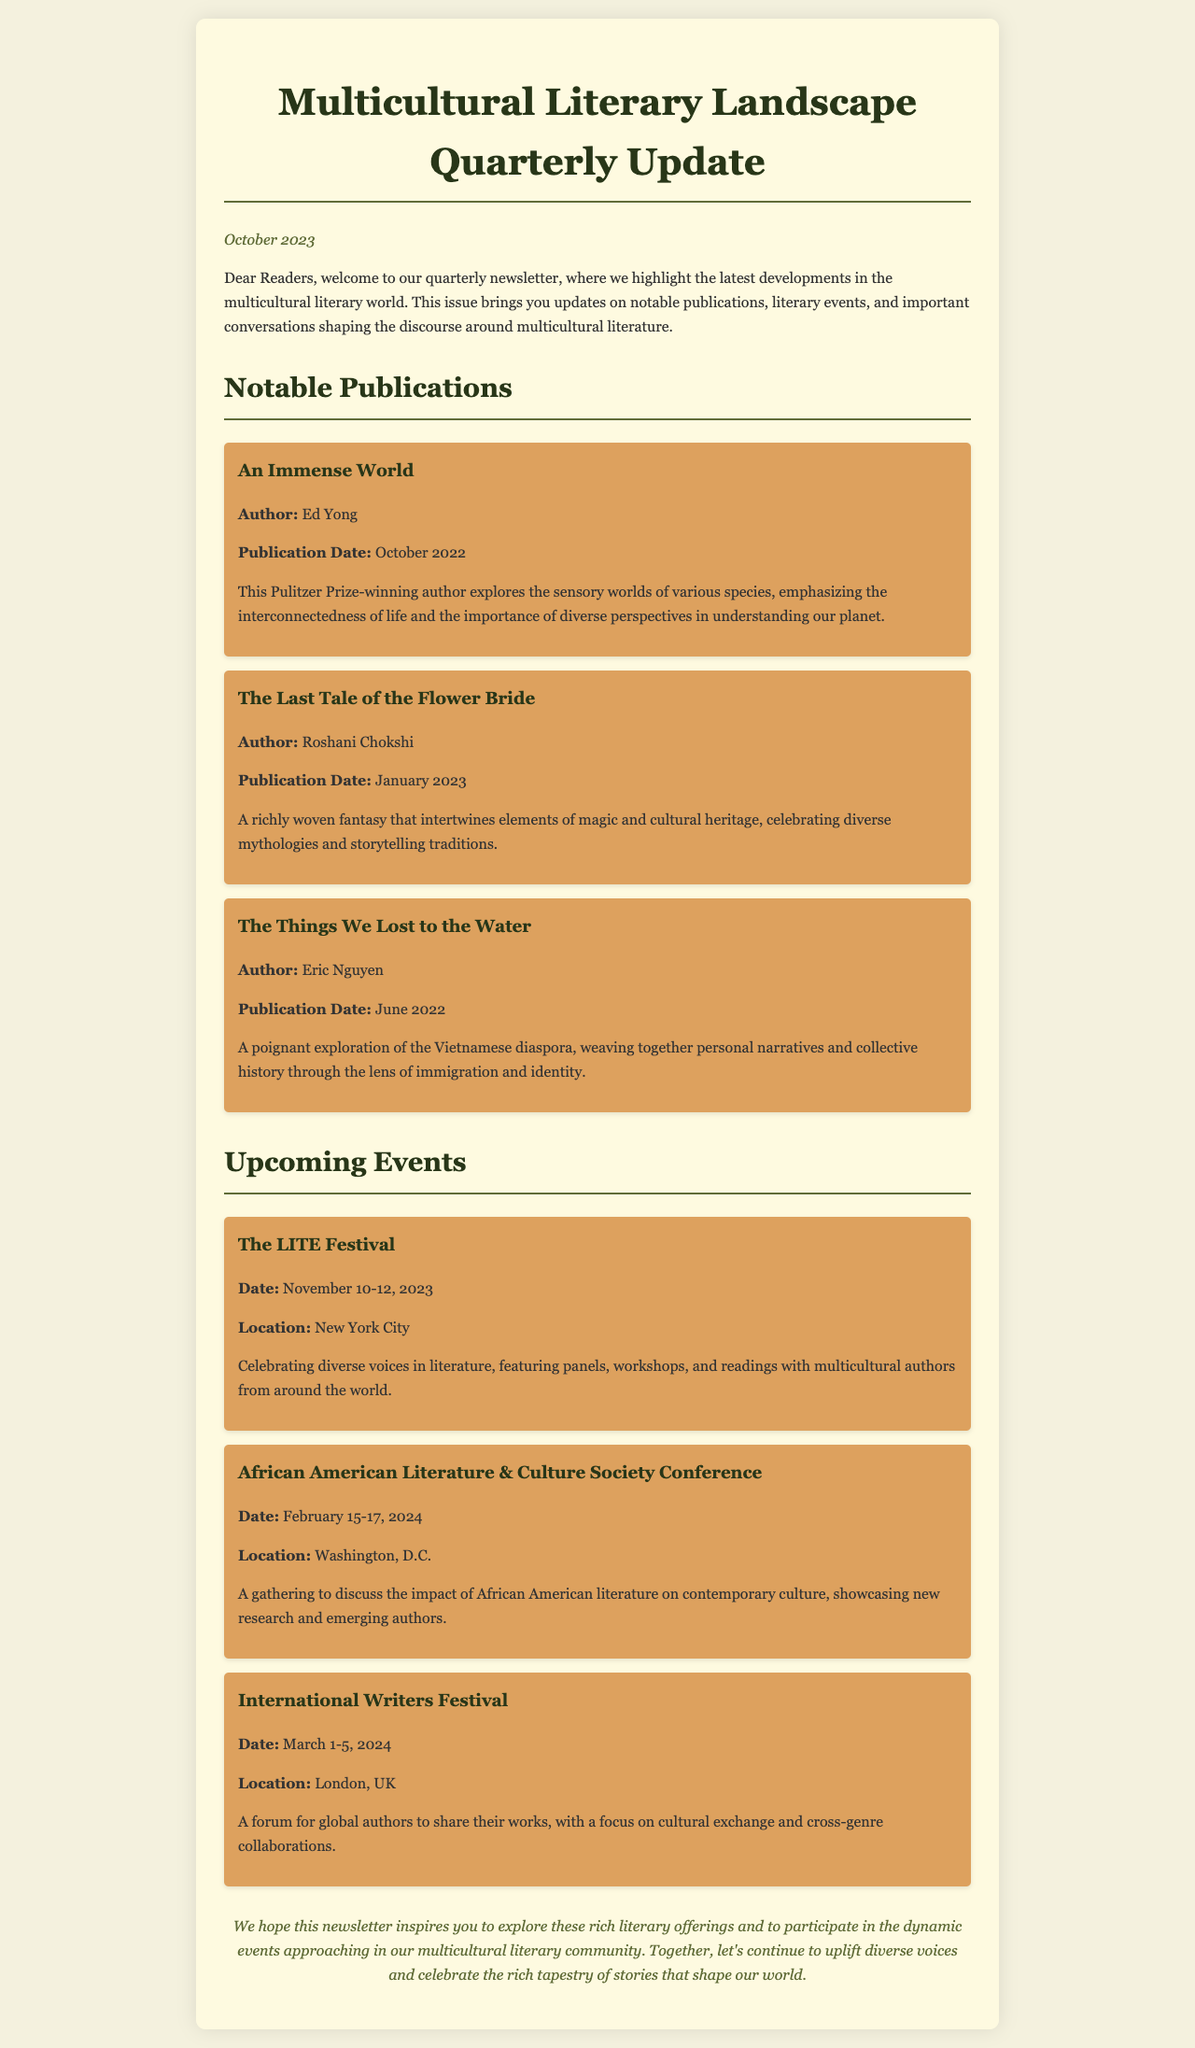What is the title of the newsletter? The title of the newsletter is stated at the top of the document, highlighting its focus on multicultural literature.
Answer: Multicultural Literary Landscape Quarterly Update Who is the author of "The Last Tale of the Flower Bride"? The author's name is provided alongside the title of the publication within the notable publications section of the newsletter.
Answer: Roshani Chokshi When will The LITE Festival take place? The date of The LITE Festival is listed in the upcoming events section, indicating when the event will occur.
Answer: November 10-12, 2023 Which publication explores the Vietnamese diaspora? The newsletter presents various notable publications, among which one focuses on the Vietnamese diaspora.
Answer: The Things We Lost to the Water How many notable publications are mentioned in the document? The document provides a list of notable publications, and the count can be obtained from that section.
Answer: Three What is the location of the International Writers Festival? The location for the International Writers Festival is indicated in its respective upcoming events section in the newsletter.
Answer: London, UK What type of event is the African American Literature & Culture Society Conference? This event is categorized in the newsletter, allowing for an understanding of its focus and theme.
Answer: Conference What important theme is emphasized in Ed Yong's book? The thematic focus of Ed Yong's publication is noted in the description section of the notable publications.
Answer: Interconnectedness of life 